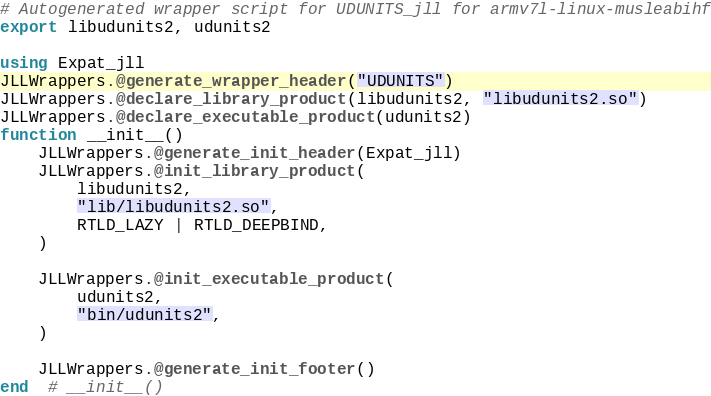Convert code to text. <code><loc_0><loc_0><loc_500><loc_500><_Julia_># Autogenerated wrapper script for UDUNITS_jll for armv7l-linux-musleabihf
export libudunits2, udunits2

using Expat_jll
JLLWrappers.@generate_wrapper_header("UDUNITS")
JLLWrappers.@declare_library_product(libudunits2, "libudunits2.so")
JLLWrappers.@declare_executable_product(udunits2)
function __init__()
    JLLWrappers.@generate_init_header(Expat_jll)
    JLLWrappers.@init_library_product(
        libudunits2,
        "lib/libudunits2.so",
        RTLD_LAZY | RTLD_DEEPBIND,
    )

    JLLWrappers.@init_executable_product(
        udunits2,
        "bin/udunits2",
    )

    JLLWrappers.@generate_init_footer()
end  # __init__()
</code> 